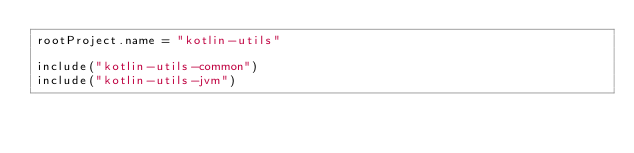<code> <loc_0><loc_0><loc_500><loc_500><_Kotlin_>rootProject.name = "kotlin-utils"

include("kotlin-utils-common")
include("kotlin-utils-jvm")
</code> 